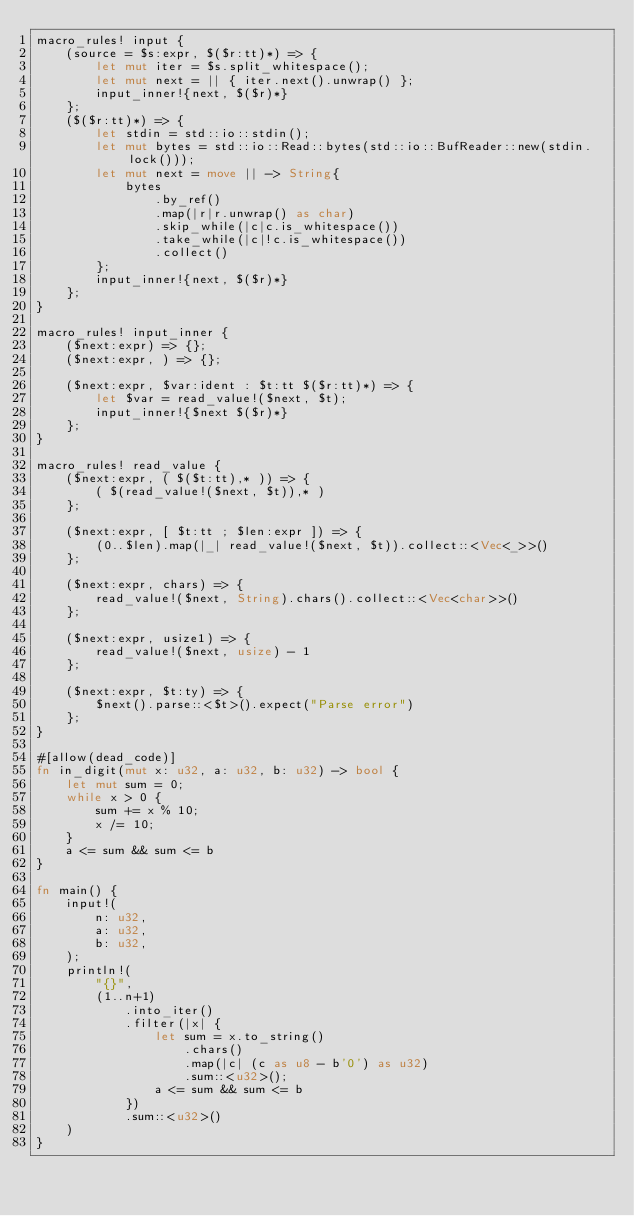Convert code to text. <code><loc_0><loc_0><loc_500><loc_500><_Rust_>macro_rules! input {
    (source = $s:expr, $($r:tt)*) => {
        let mut iter = $s.split_whitespace();
        let mut next = || { iter.next().unwrap() };
        input_inner!{next, $($r)*}
    };
    ($($r:tt)*) => {
        let stdin = std::io::stdin();
        let mut bytes = std::io::Read::bytes(std::io::BufReader::new(stdin.lock()));
        let mut next = move || -> String{
            bytes
                .by_ref()
                .map(|r|r.unwrap() as char)
                .skip_while(|c|c.is_whitespace())
                .take_while(|c|!c.is_whitespace())
                .collect()
        };
        input_inner!{next, $($r)*}
    };
}

macro_rules! input_inner {
    ($next:expr) => {};
    ($next:expr, ) => {};

    ($next:expr, $var:ident : $t:tt $($r:tt)*) => {
        let $var = read_value!($next, $t);
        input_inner!{$next $($r)*}
    };
}

macro_rules! read_value {
    ($next:expr, ( $($t:tt),* )) => {
        ( $(read_value!($next, $t)),* )
    };

    ($next:expr, [ $t:tt ; $len:expr ]) => {
        (0..$len).map(|_| read_value!($next, $t)).collect::<Vec<_>>()
    };

    ($next:expr, chars) => {
        read_value!($next, String).chars().collect::<Vec<char>>()
    };

    ($next:expr, usize1) => {
        read_value!($next, usize) - 1
    };

    ($next:expr, $t:ty) => {
        $next().parse::<$t>().expect("Parse error")
    };
}

#[allow(dead_code)]
fn in_digit(mut x: u32, a: u32, b: u32) -> bool {
    let mut sum = 0;
    while x > 0 {
        sum += x % 10;
        x /= 10;
    }
    a <= sum && sum <= b
}

fn main() {
    input!(
        n: u32,
        a: u32,
        b: u32,
    );
    println!(
        "{}",
        (1..n+1)
            .into_iter()
            .filter(|x| {
                let sum = x.to_string()
                    .chars()
                    .map(|c| (c as u8 - b'0') as u32)
                    .sum::<u32>();
                a <= sum && sum <= b
            })
            .sum::<u32>()
    )
}
</code> 